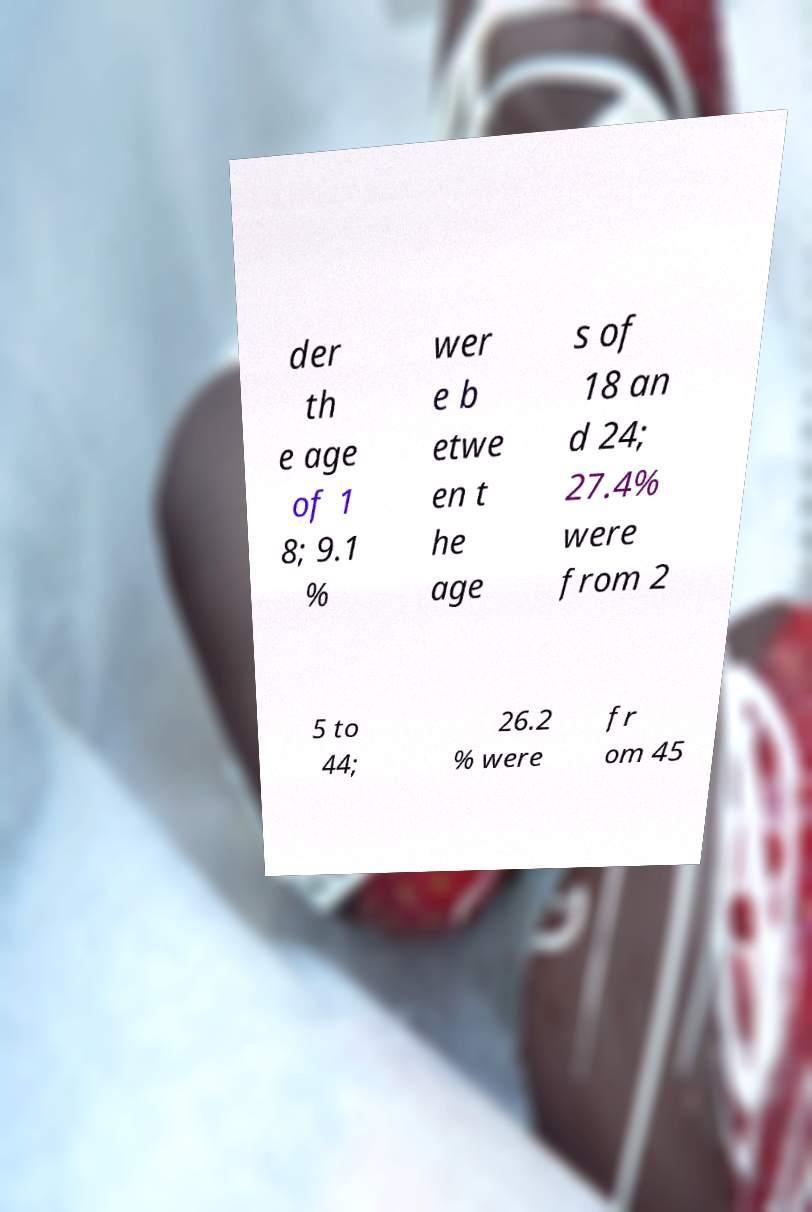What messages or text are displayed in this image? I need them in a readable, typed format. der th e age of 1 8; 9.1 % wer e b etwe en t he age s of 18 an d 24; 27.4% were from 2 5 to 44; 26.2 % were fr om 45 